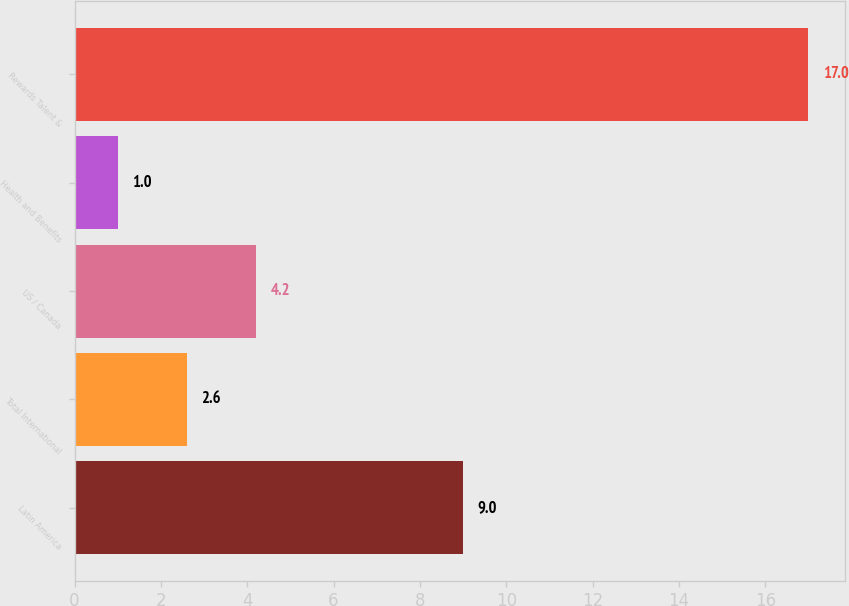Convert chart. <chart><loc_0><loc_0><loc_500><loc_500><bar_chart><fcel>Latin America<fcel>Total International<fcel>US / Canada<fcel>Health and Benefits<fcel>Rewards Talent &<nl><fcel>9<fcel>2.6<fcel>4.2<fcel>1<fcel>17<nl></chart> 